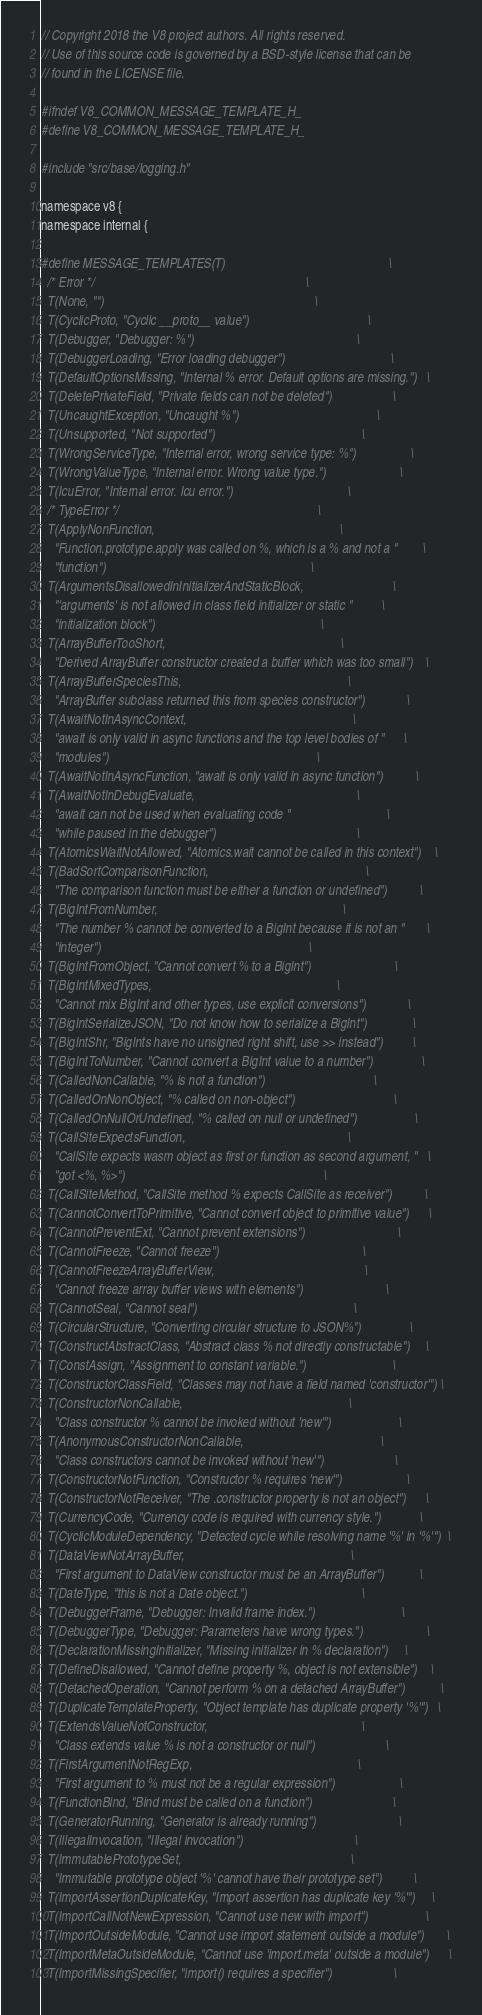<code> <loc_0><loc_0><loc_500><loc_500><_C_>// Copyright 2018 the V8 project authors. All rights reserved.
// Use of this source code is governed by a BSD-style license that can be
// found in the LICENSE file.

#ifndef V8_COMMON_MESSAGE_TEMPLATE_H_
#define V8_COMMON_MESSAGE_TEMPLATE_H_

#include "src/base/logging.h"

namespace v8 {
namespace internal {

#define MESSAGE_TEMPLATES(T)                                                   \
  /* Error */                                                                  \
  T(None, "")                                                                  \
  T(CyclicProto, "Cyclic __proto__ value")                                     \
  T(Debugger, "Debugger: %")                                                   \
  T(DebuggerLoading, "Error loading debugger")                                 \
  T(DefaultOptionsMissing, "Internal % error. Default options are missing.")   \
  T(DeletePrivateField, "Private fields can not be deleted")                   \
  T(UncaughtException, "Uncaught %")                                           \
  T(Unsupported, "Not supported")                                              \
  T(WrongServiceType, "Internal error, wrong service type: %")                 \
  T(WrongValueType, "Internal error. Wrong value type.")                       \
  T(IcuError, "Internal error. Icu error.")                                    \
  /* TypeError */                                                              \
  T(ApplyNonFunction,                                                          \
    "Function.prototype.apply was called on %, which is a % and not a "        \
    "function")                                                                \
  T(ArgumentsDisallowedInInitializerAndStaticBlock,                            \
    "'arguments' is not allowed in class field initializer or static "         \
    "initialization block")                                                    \
  T(ArrayBufferTooShort,                                                       \
    "Derived ArrayBuffer constructor created a buffer which was too small")    \
  T(ArrayBufferSpeciesThis,                                                    \
    "ArrayBuffer subclass returned this from species constructor")             \
  T(AwaitNotInAsyncContext,                                                    \
    "await is only valid in async functions and the top level bodies of "      \
    "modules")                                                                 \
  T(AwaitNotInAsyncFunction, "await is only valid in async function")          \
  T(AwaitNotInDebugEvaluate,                                                   \
    "await can not be used when evaluating code "                              \
    "while paused in the debugger")                                            \
  T(AtomicsWaitNotAllowed, "Atomics.wait cannot be called in this context")    \
  T(BadSortComparisonFunction,                                                 \
    "The comparison function must be either a function or undefined")          \
  T(BigIntFromNumber,                                                          \
    "The number % cannot be converted to a BigInt because it is not an "       \
    "integer")                                                                 \
  T(BigIntFromObject, "Cannot convert % to a BigInt")                          \
  T(BigIntMixedTypes,                                                          \
    "Cannot mix BigInt and other types, use explicit conversions")             \
  T(BigIntSerializeJSON, "Do not know how to serialize a BigInt")              \
  T(BigIntShr, "BigInts have no unsigned right shift, use >> instead")         \
  T(BigIntToNumber, "Cannot convert a BigInt value to a number")               \
  T(CalledNonCallable, "% is not a function")                                  \
  T(CalledOnNonObject, "% called on non-object")                               \
  T(CalledOnNullOrUndefined, "% called on null or undefined")                  \
  T(CallSiteExpectsFunction,                                                   \
    "CallSite expects wasm object as first or function as second argument, "   \
    "got <%, %>")                                                              \
  T(CallSiteMethod, "CallSite method % expects CallSite as receiver")          \
  T(CannotConvertToPrimitive, "Cannot convert object to primitive value")      \
  T(CannotPreventExt, "Cannot prevent extensions")                             \
  T(CannotFreeze, "Cannot freeze")                                             \
  T(CannotFreezeArrayBufferView,                                               \
    "Cannot freeze array buffer views with elements")                          \
  T(CannotSeal, "Cannot seal")                                                 \
  T(CircularStructure, "Converting circular structure to JSON%")               \
  T(ConstructAbstractClass, "Abstract class % not directly constructable")     \
  T(ConstAssign, "Assignment to constant variable.")                           \
  T(ConstructorClassField, "Classes may not have a field named 'constructor'") \
  T(ConstructorNonCallable,                                                    \
    "Class constructor % cannot be invoked without 'new'")                     \
  T(AnonymousConstructorNonCallable,                                           \
    "Class constructors cannot be invoked without 'new'")                      \
  T(ConstructorNotFunction, "Constructor % requires 'new'")                    \
  T(ConstructorNotReceiver, "The .constructor property is not an object")      \
  T(CurrencyCode, "Currency code is required with currency style.")            \
  T(CyclicModuleDependency, "Detected cycle while resolving name '%' in '%'")  \
  T(DataViewNotArrayBuffer,                                                    \
    "First argument to DataView constructor must be an ArrayBuffer")           \
  T(DateType, "this is not a Date object.")                                    \
  T(DebuggerFrame, "Debugger: Invalid frame index.")                           \
  T(DebuggerType, "Debugger: Parameters have wrong types.")                    \
  T(DeclarationMissingInitializer, "Missing initializer in % declaration")     \
  T(DefineDisallowed, "Cannot define property %, object is not extensible")    \
  T(DetachedOperation, "Cannot perform % on a detached ArrayBuffer")           \
  T(DuplicateTemplateProperty, "Object template has duplicate property '%'")   \
  T(ExtendsValueNotConstructor,                                                \
    "Class extends value % is not a constructor or null")                      \
  T(FirstArgumentNotRegExp,                                                    \
    "First argument to % must not be a regular expression")                    \
  T(FunctionBind, "Bind must be called on a function")                         \
  T(GeneratorRunning, "Generator is already running")                          \
  T(IllegalInvocation, "Illegal invocation")                                   \
  T(ImmutablePrototypeSet,                                                     \
    "Immutable prototype object '%' cannot have their prototype set")          \
  T(ImportAssertionDuplicateKey, "Import assertion has duplicate key '%'")     \
  T(ImportCallNotNewExpression, "Cannot use new with import")                  \
  T(ImportOutsideModule, "Cannot use import statement outside a module")       \
  T(ImportMetaOutsideModule, "Cannot use 'import.meta' outside a module")      \
  T(ImportMissingSpecifier, "import() requires a specifier")                   \</code> 